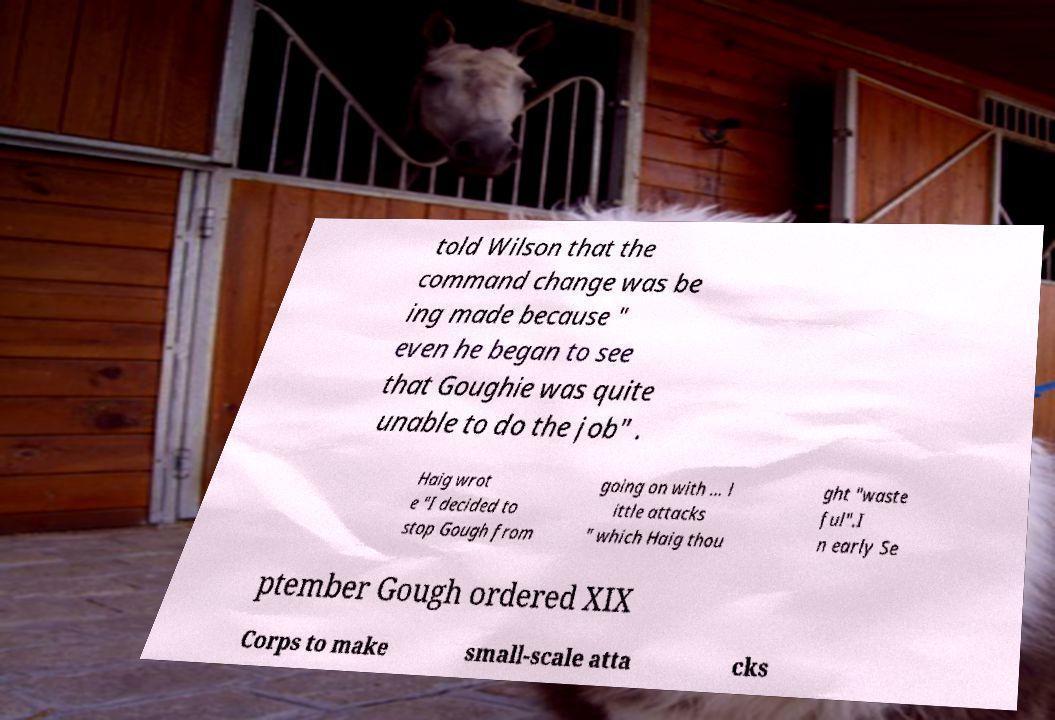Please read and relay the text visible in this image. What does it say? told Wilson that the command change was be ing made because " even he began to see that Goughie was quite unable to do the job" . Haig wrot e "I decided to stop Gough from going on with ... l ittle attacks " which Haig thou ght "waste ful".I n early Se ptember Gough ordered XIX Corps to make small-scale atta cks 